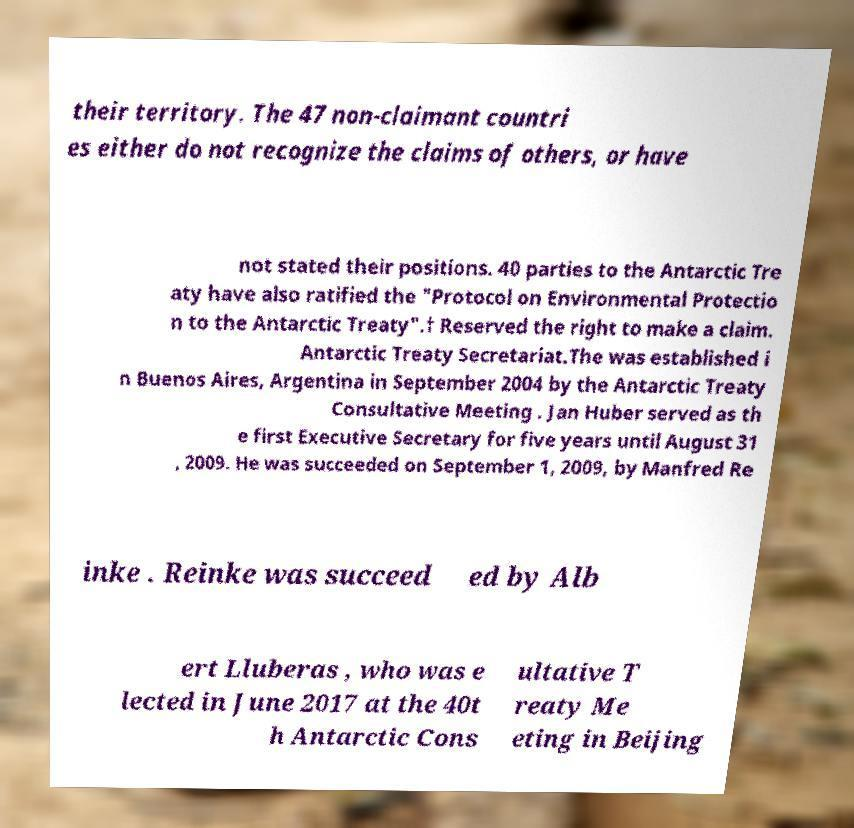Can you read and provide the text displayed in the image?This photo seems to have some interesting text. Can you extract and type it out for me? their territory. The 47 non-claimant countri es either do not recognize the claims of others, or have not stated their positions. 40 parties to the Antarctic Tre aty have also ratified the "Protocol on Environmental Protectio n to the Antarctic Treaty".† Reserved the right to make a claim. Antarctic Treaty Secretariat.The was established i n Buenos Aires, Argentina in September 2004 by the Antarctic Treaty Consultative Meeting . Jan Huber served as th e first Executive Secretary for five years until August 31 , 2009. He was succeeded on September 1, 2009, by Manfred Re inke . Reinke was succeed ed by Alb ert Lluberas , who was e lected in June 2017 at the 40t h Antarctic Cons ultative T reaty Me eting in Beijing 